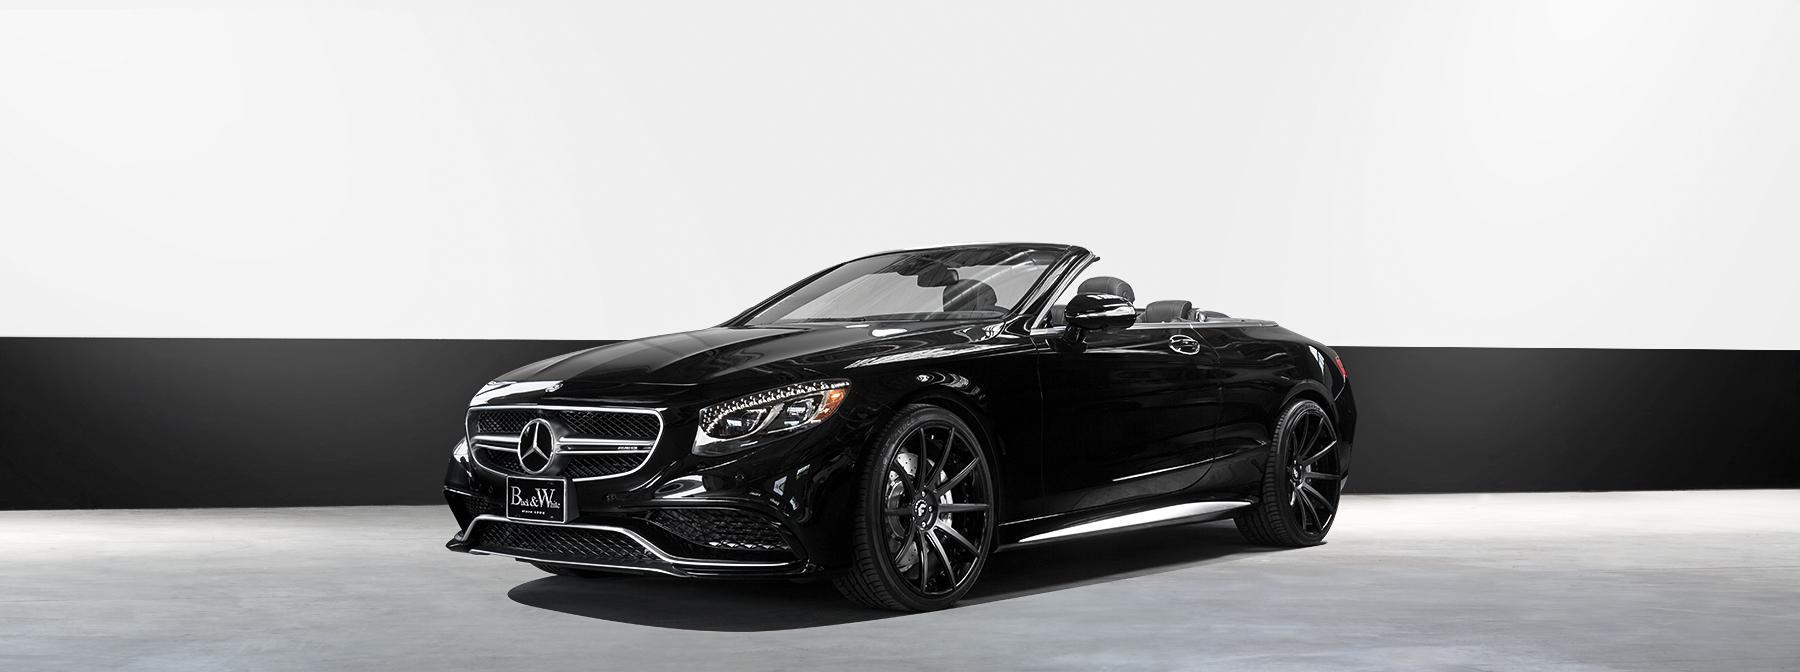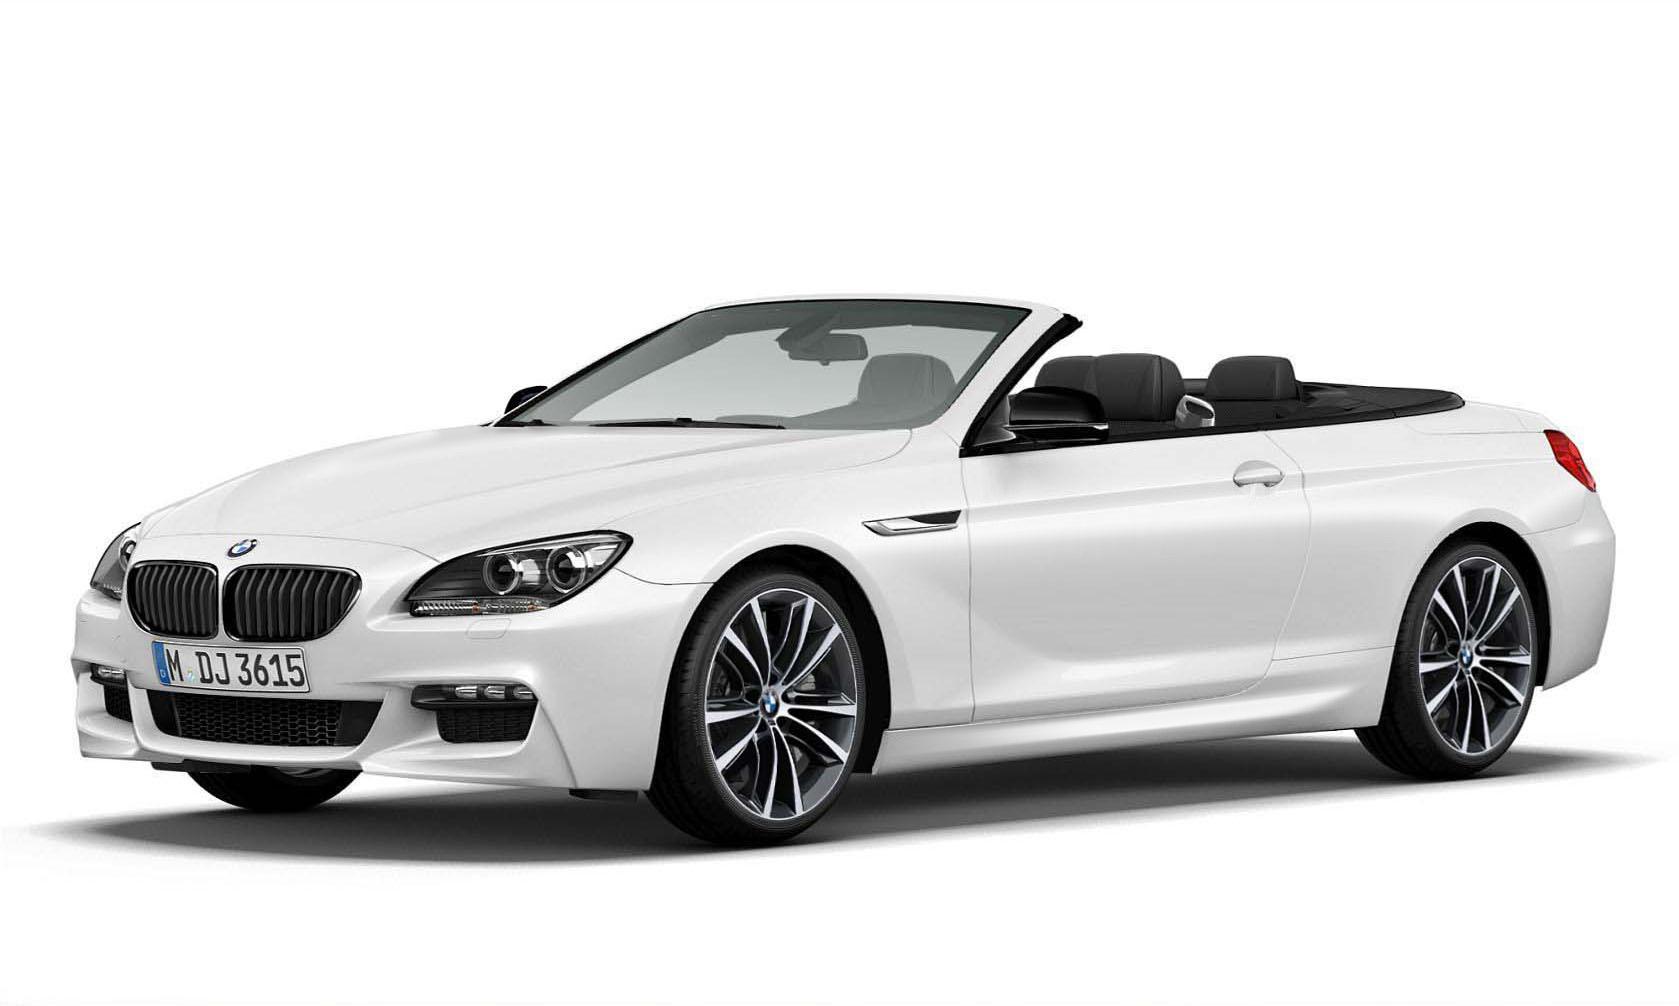The first image is the image on the left, the second image is the image on the right. For the images shown, is this caption "There is no less than one black convertible car with its top down" true? Answer yes or no. Yes. The first image is the image on the left, the second image is the image on the right. Considering the images on both sides, is "One image shows a topless black convertible aimed leftward." valid? Answer yes or no. Yes. 